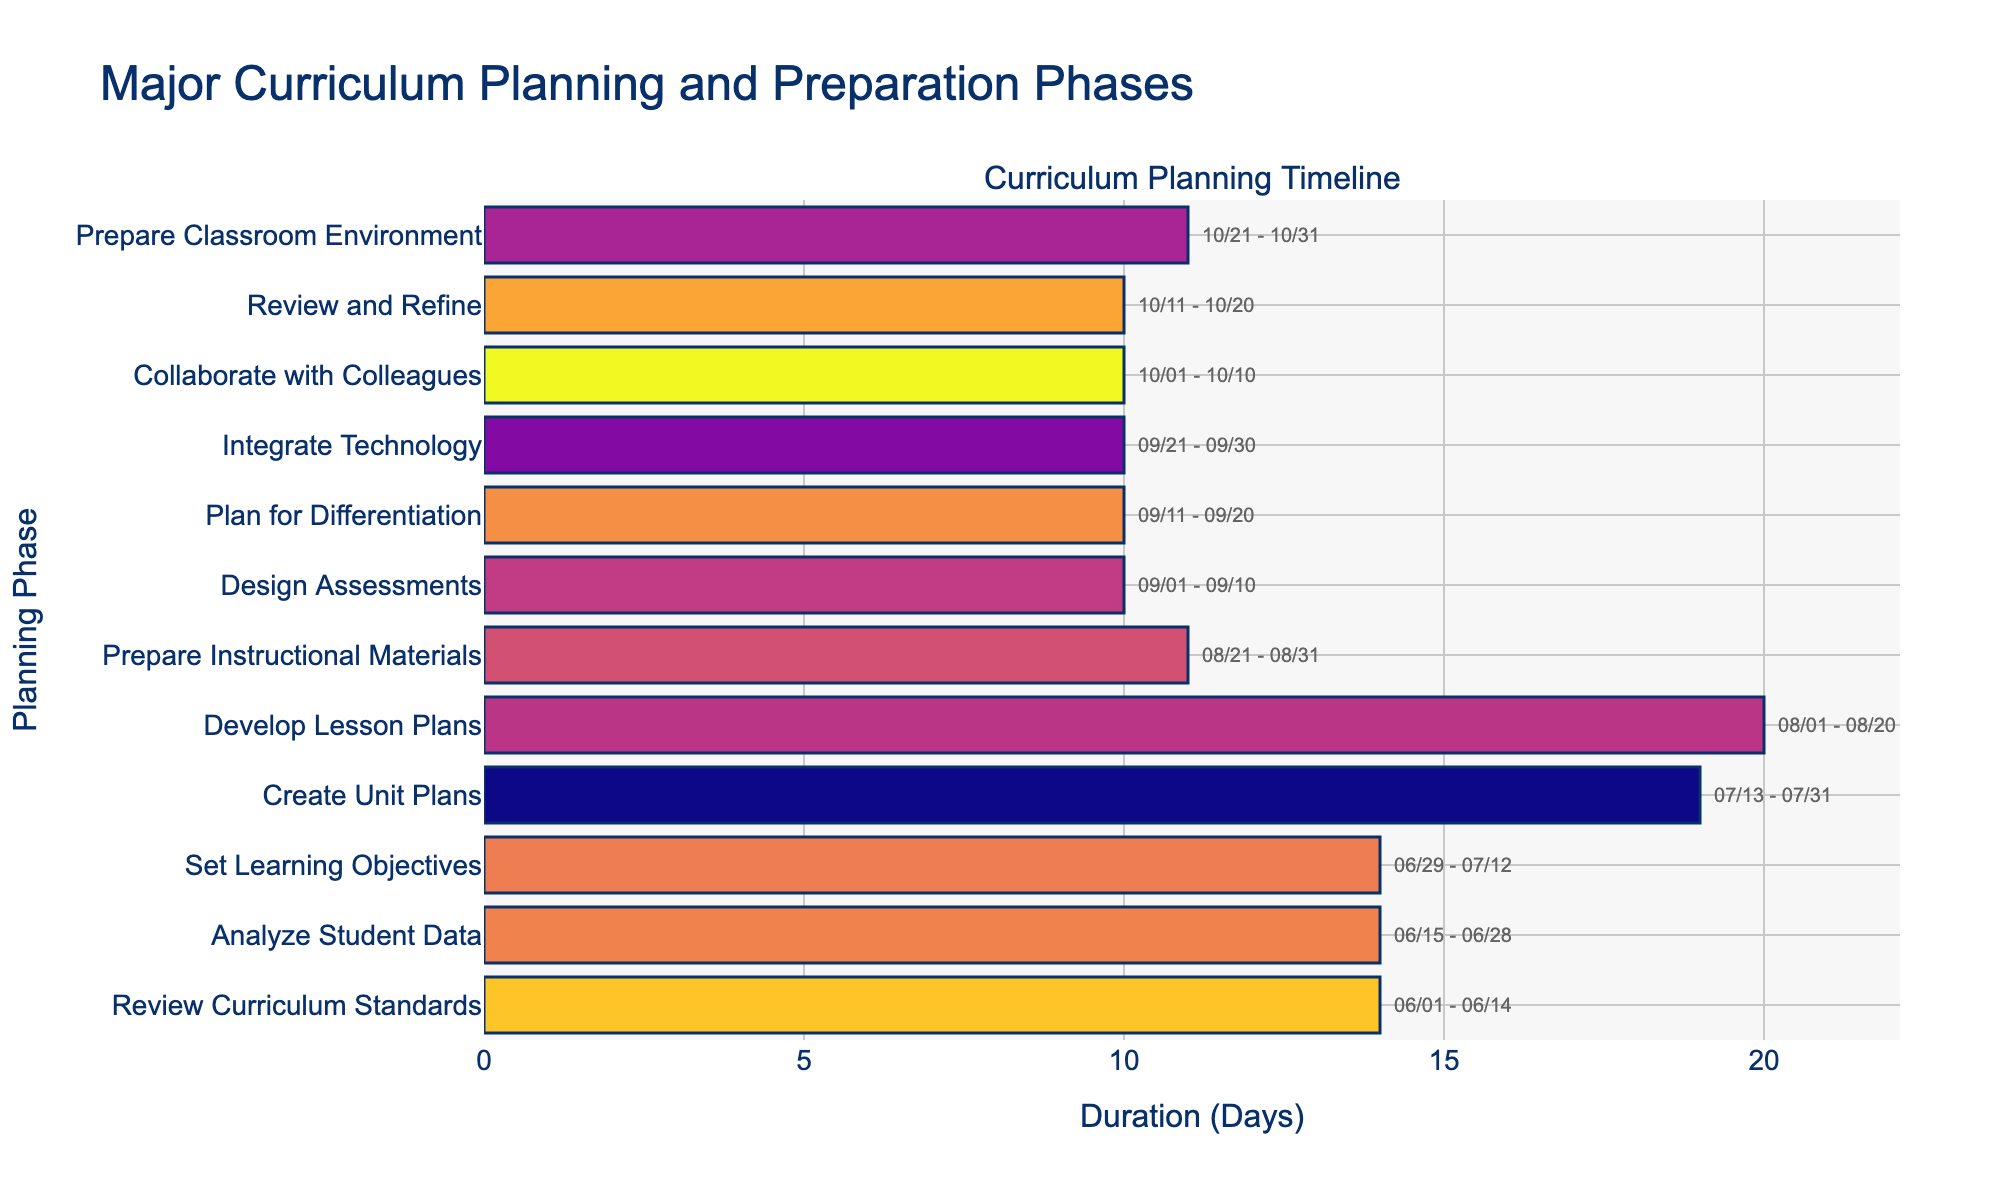What is the duration of the "Review Curriculum Standards" phase? The "Review Curriculum Standards" phase starts on June 1, 2023, and ends on June 14, 2023. To calculate the duration, I subtract the start date from the end date: June 14 - June 1 = 13 days. Therefore, the duration is 13 days.
Answer: 14 days Which phase has the longest duration? By reviewing the duration of each phase, we see that the "Create Unit Plans" phase lasts from July 13 to July 31, which is 19 days. This is longer compared to other phases.
Answer: Create Unit Plans How many phases are planned between June 1 and June 30? I will count the phases that start before or on June 30. "Review Curriculum Standards" (June 1), "Analyze Student Data" (June 15), and "Set Learning Objectives" (June 29) are within this date range. Therefore, there are three phases in total.
Answer: 3 Is it true that the "Prepare Instructional Materials" phase follows the "Develop Lesson Plans" phase? The "Develop Lesson Plans" phase ends on August 20, and the "Prepare Instructional Materials" phase starts on August 21. Therefore, it is correct that "Prepare Instructional Materials" follows "Develop Lesson Plans."
Answer: Yes What is the total duration of all planning phases from start to end? First, I will sum the durations of each planning phase: 14 (Review Curriculum Standards) + 14 (Analyze Student Data) + 14 (Set Learning Objectives) + 19 (Create Unit Plans) + 20 (Develop Lesson Plans) + 11 (Prepare Instructional Materials) + 10 (Design Assessments) + 10 (Plan for Differentiation) + 10 (Integrate Technology) + 10 (Collaborate with Colleagues) + 10 (Review and Refine) + 11 (Prepare Classroom Environment) =  154. Therefore, the total duration of all planning phases is 154 days.
Answer: 154 days 